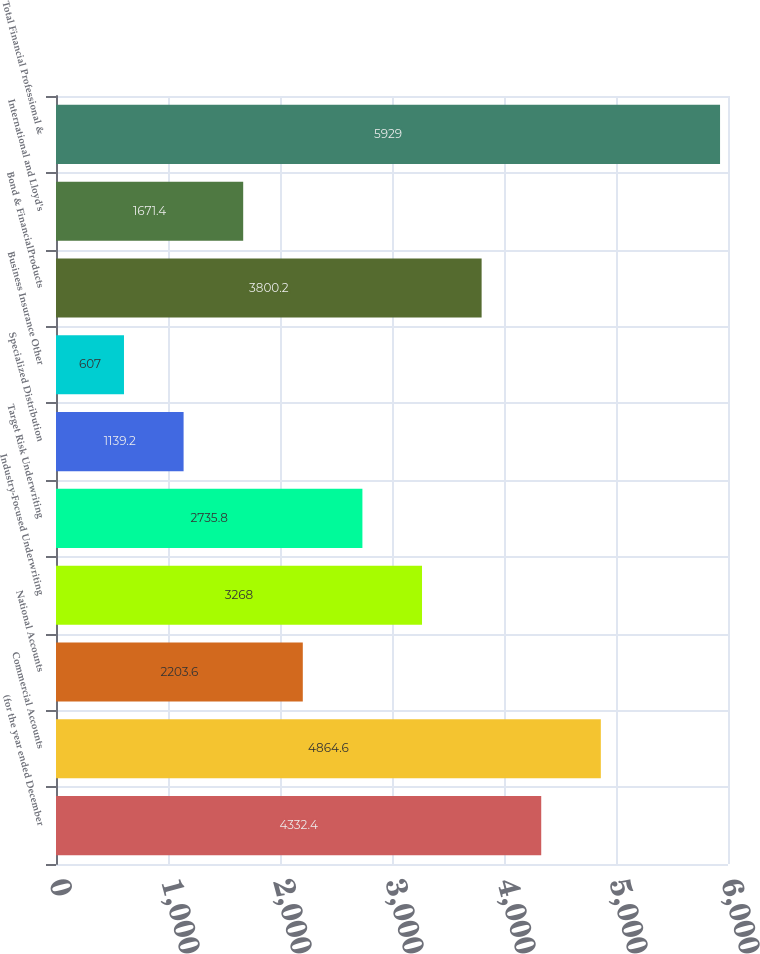<chart> <loc_0><loc_0><loc_500><loc_500><bar_chart><fcel>(for the year ended December<fcel>Commercial Accounts<fcel>National Accounts<fcel>Industry-Focused Underwriting<fcel>Target Risk Underwriting<fcel>Specialized Distribution<fcel>Business Insurance Other<fcel>Bond & FinancialProducts<fcel>International and Lloyd's<fcel>Total Financial Professional &<nl><fcel>4332.4<fcel>4864.6<fcel>2203.6<fcel>3268<fcel>2735.8<fcel>1139.2<fcel>607<fcel>3800.2<fcel>1671.4<fcel>5929<nl></chart> 